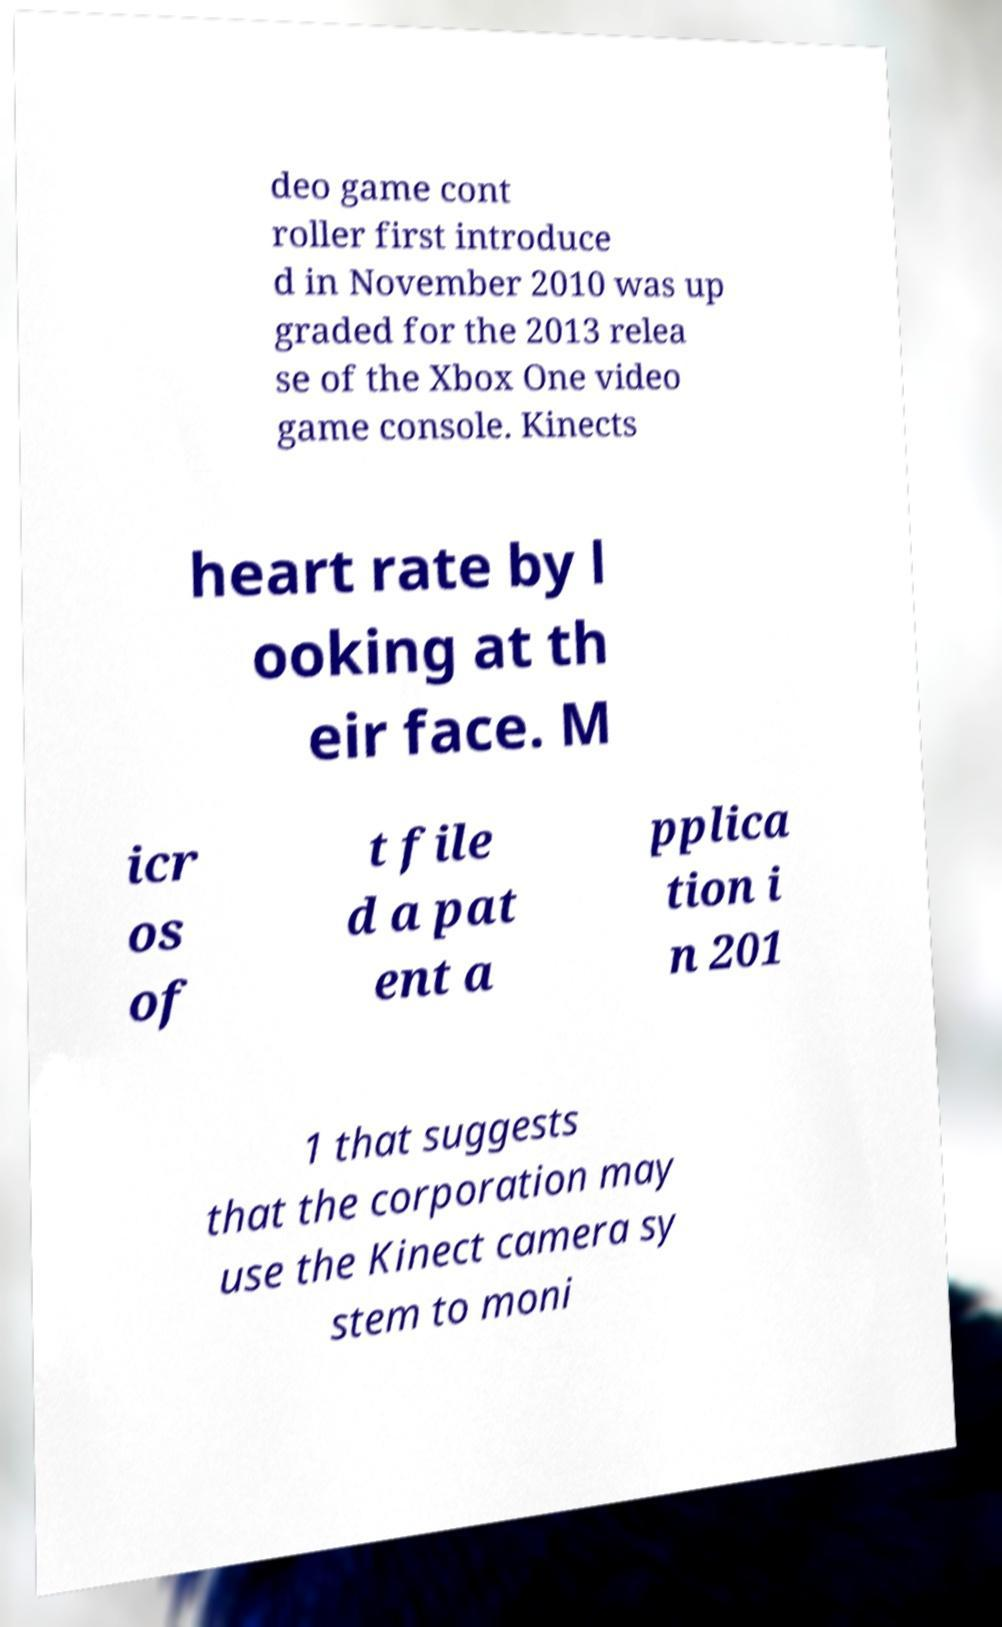Could you assist in decoding the text presented in this image and type it out clearly? deo game cont roller first introduce d in November 2010 was up graded for the 2013 relea se of the Xbox One video game console. Kinects heart rate by l ooking at th eir face. M icr os of t file d a pat ent a pplica tion i n 201 1 that suggests that the corporation may use the Kinect camera sy stem to moni 